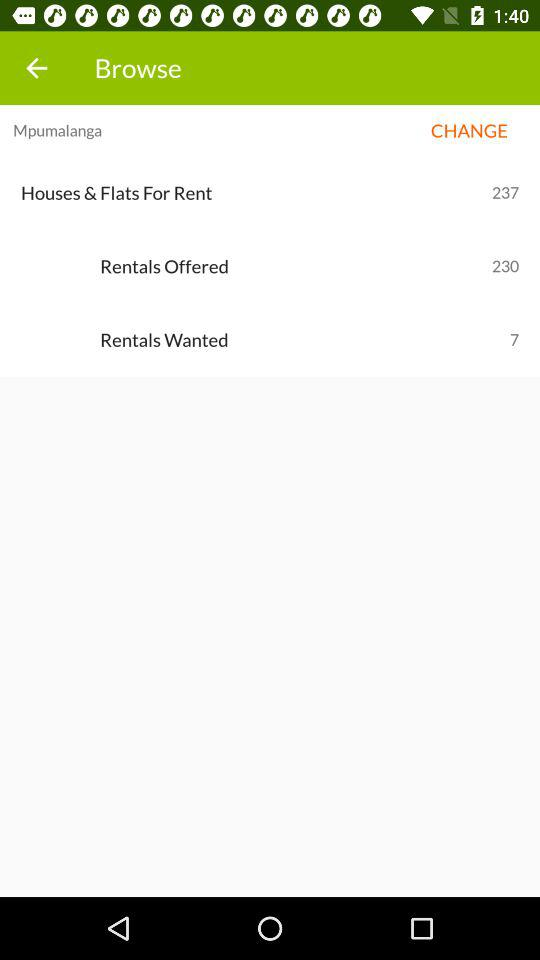How many houses and flats are for rent? There are 237 houses and flats for rent. 